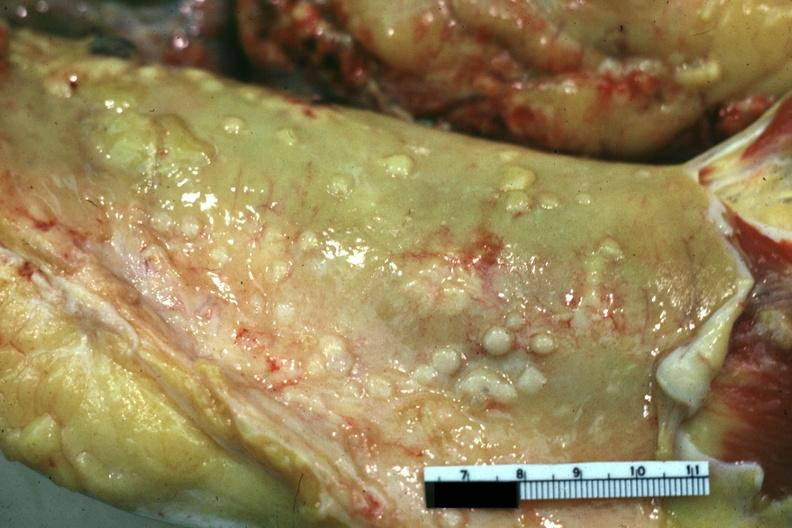where is this area in the body?
Answer the question using a single word or phrase. Abdomen 